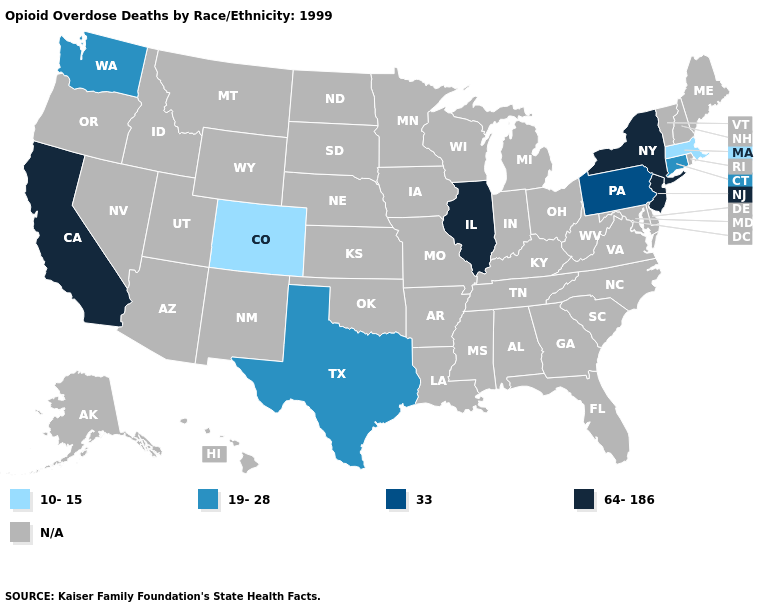Name the states that have a value in the range 33?
Short answer required. Pennsylvania. What is the value of New Mexico?
Keep it brief. N/A. What is the lowest value in the USA?
Short answer required. 10-15. Does Connecticut have the lowest value in the Northeast?
Short answer required. No. Name the states that have a value in the range 33?
Be succinct. Pennsylvania. Which states have the highest value in the USA?
Concise answer only. California, Illinois, New Jersey, New York. What is the highest value in the USA?
Concise answer only. 64-186. What is the value of West Virginia?
Be succinct. N/A. What is the lowest value in states that border Louisiana?
Give a very brief answer. 19-28. What is the value of Tennessee?
Concise answer only. N/A. 